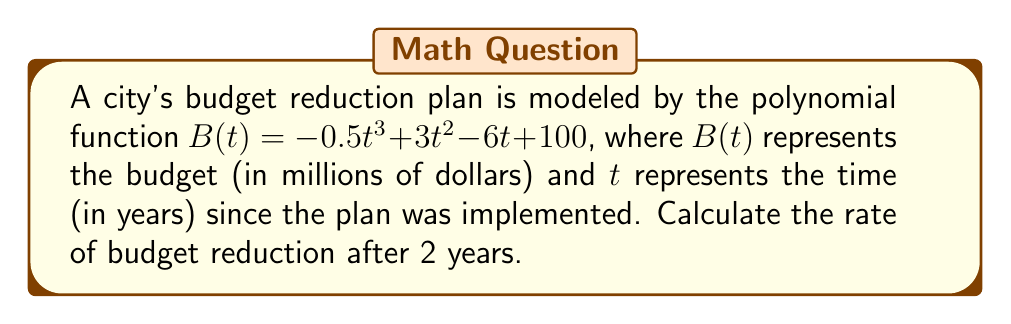Can you answer this question? To find the rate of budget reduction at a specific point in time, we need to calculate the derivative of the budget function $B(t)$ and evaluate it at $t = 2$.

1. First, let's find the derivative of $B(t)$:
   $$B'(t) = \frac{d}{dt}(-0.5t^3 + 3t^2 - 6t + 100)$$
   $$B'(t) = -1.5t^2 + 6t - 6$$

2. Now, we evaluate $B'(t)$ at $t = 2$:
   $$B'(2) = -1.5(2)^2 + 6(2) - 6$$
   $$B'(2) = -1.5(4) + 12 - 6$$
   $$B'(2) = -6 + 12 - 6$$
   $$B'(2) = 0$$

3. The rate of budget reduction is the negative of the derivative:
   Rate of budget reduction = $-B'(2) = -(0) = 0$

This means that after 2 years, the rate of budget reduction is 0 million dollars per year. In other words, the budget has momentarily stabilized at the 2-year mark, neither increasing nor decreasing at that specific point in time.
Answer: 0 million dollars per year 